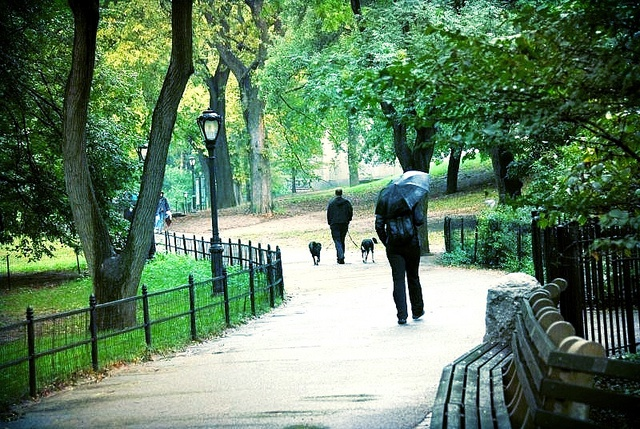Describe the objects in this image and their specific colors. I can see bench in black, teal, and purple tones, people in black, blue, darkblue, and white tones, umbrella in black, blue, teal, and lightblue tones, people in black, blue, darkblue, and teal tones, and dog in black, ivory, darkgray, and gray tones in this image. 